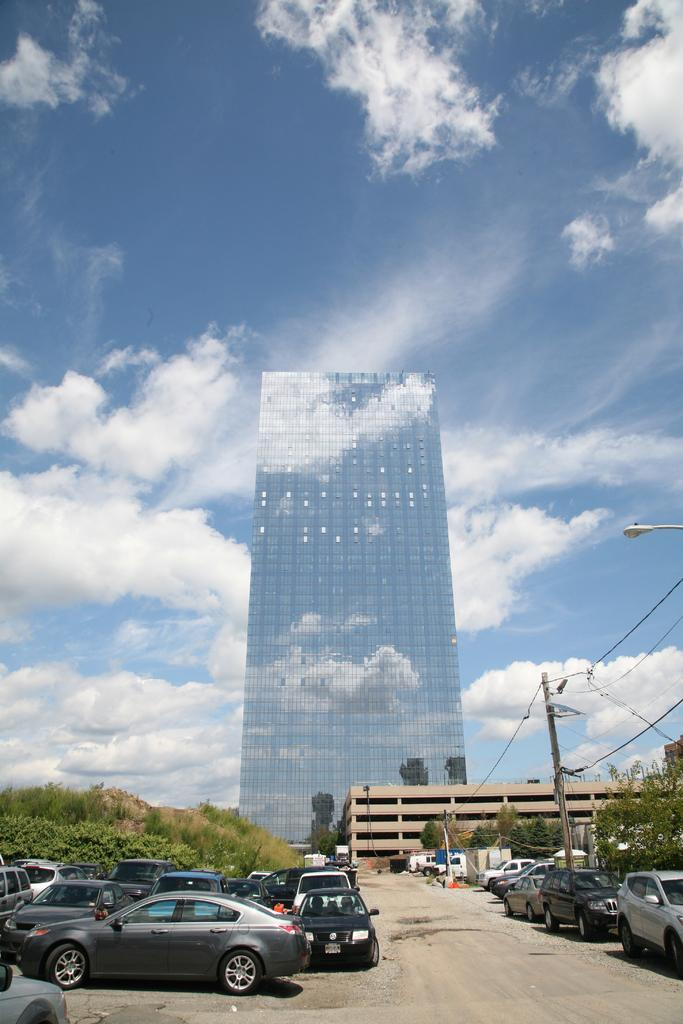What type of vehicles can be seen in the image? There are cars in the image. What natural elements are present in the image? There are trees in the image. What infrastructure elements can be seen in the image? Electric poles with cables and lamp posts are visible in the image. What type of structures are present in the image? There are buildings in the image. What can be seen in the sky at the top of the image? Clouds are visible in the sky at the top of the image. Can you tell me how many rabbits are hopping around the cars in the image? There are no rabbits present in the image; it features cars, trees, electric poles, lamp posts, buildings, and clouds. Is there a carpenter working on the buildings in the image? There is no carpenter visible in the image; it only shows cars, trees, electric poles, lamp posts, buildings, and clouds. 